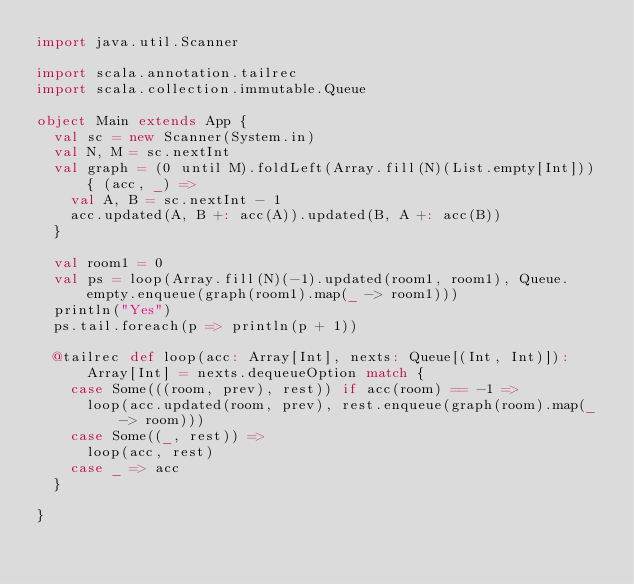Convert code to text. <code><loc_0><loc_0><loc_500><loc_500><_Scala_>import java.util.Scanner

import scala.annotation.tailrec
import scala.collection.immutable.Queue

object Main extends App {
  val sc = new Scanner(System.in)
  val N, M = sc.nextInt
  val graph = (0 until M).foldLeft(Array.fill(N)(List.empty[Int])) { (acc, _) =>
    val A, B = sc.nextInt - 1
    acc.updated(A, B +: acc(A)).updated(B, A +: acc(B))
  }

  val room1 = 0
  val ps = loop(Array.fill(N)(-1).updated(room1, room1), Queue.empty.enqueue(graph(room1).map(_ -> room1)))
  println("Yes")
  ps.tail.foreach(p => println(p + 1))

  @tailrec def loop(acc: Array[Int], nexts: Queue[(Int, Int)]): Array[Int] = nexts.dequeueOption match {
    case Some(((room, prev), rest)) if acc(room) == -1 =>
      loop(acc.updated(room, prev), rest.enqueue(graph(room).map(_ -> room)))
    case Some((_, rest)) =>
      loop(acc, rest)
    case _ => acc
  }

}
</code> 